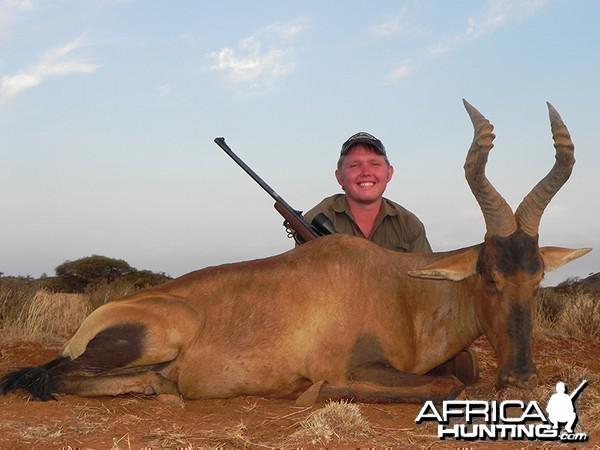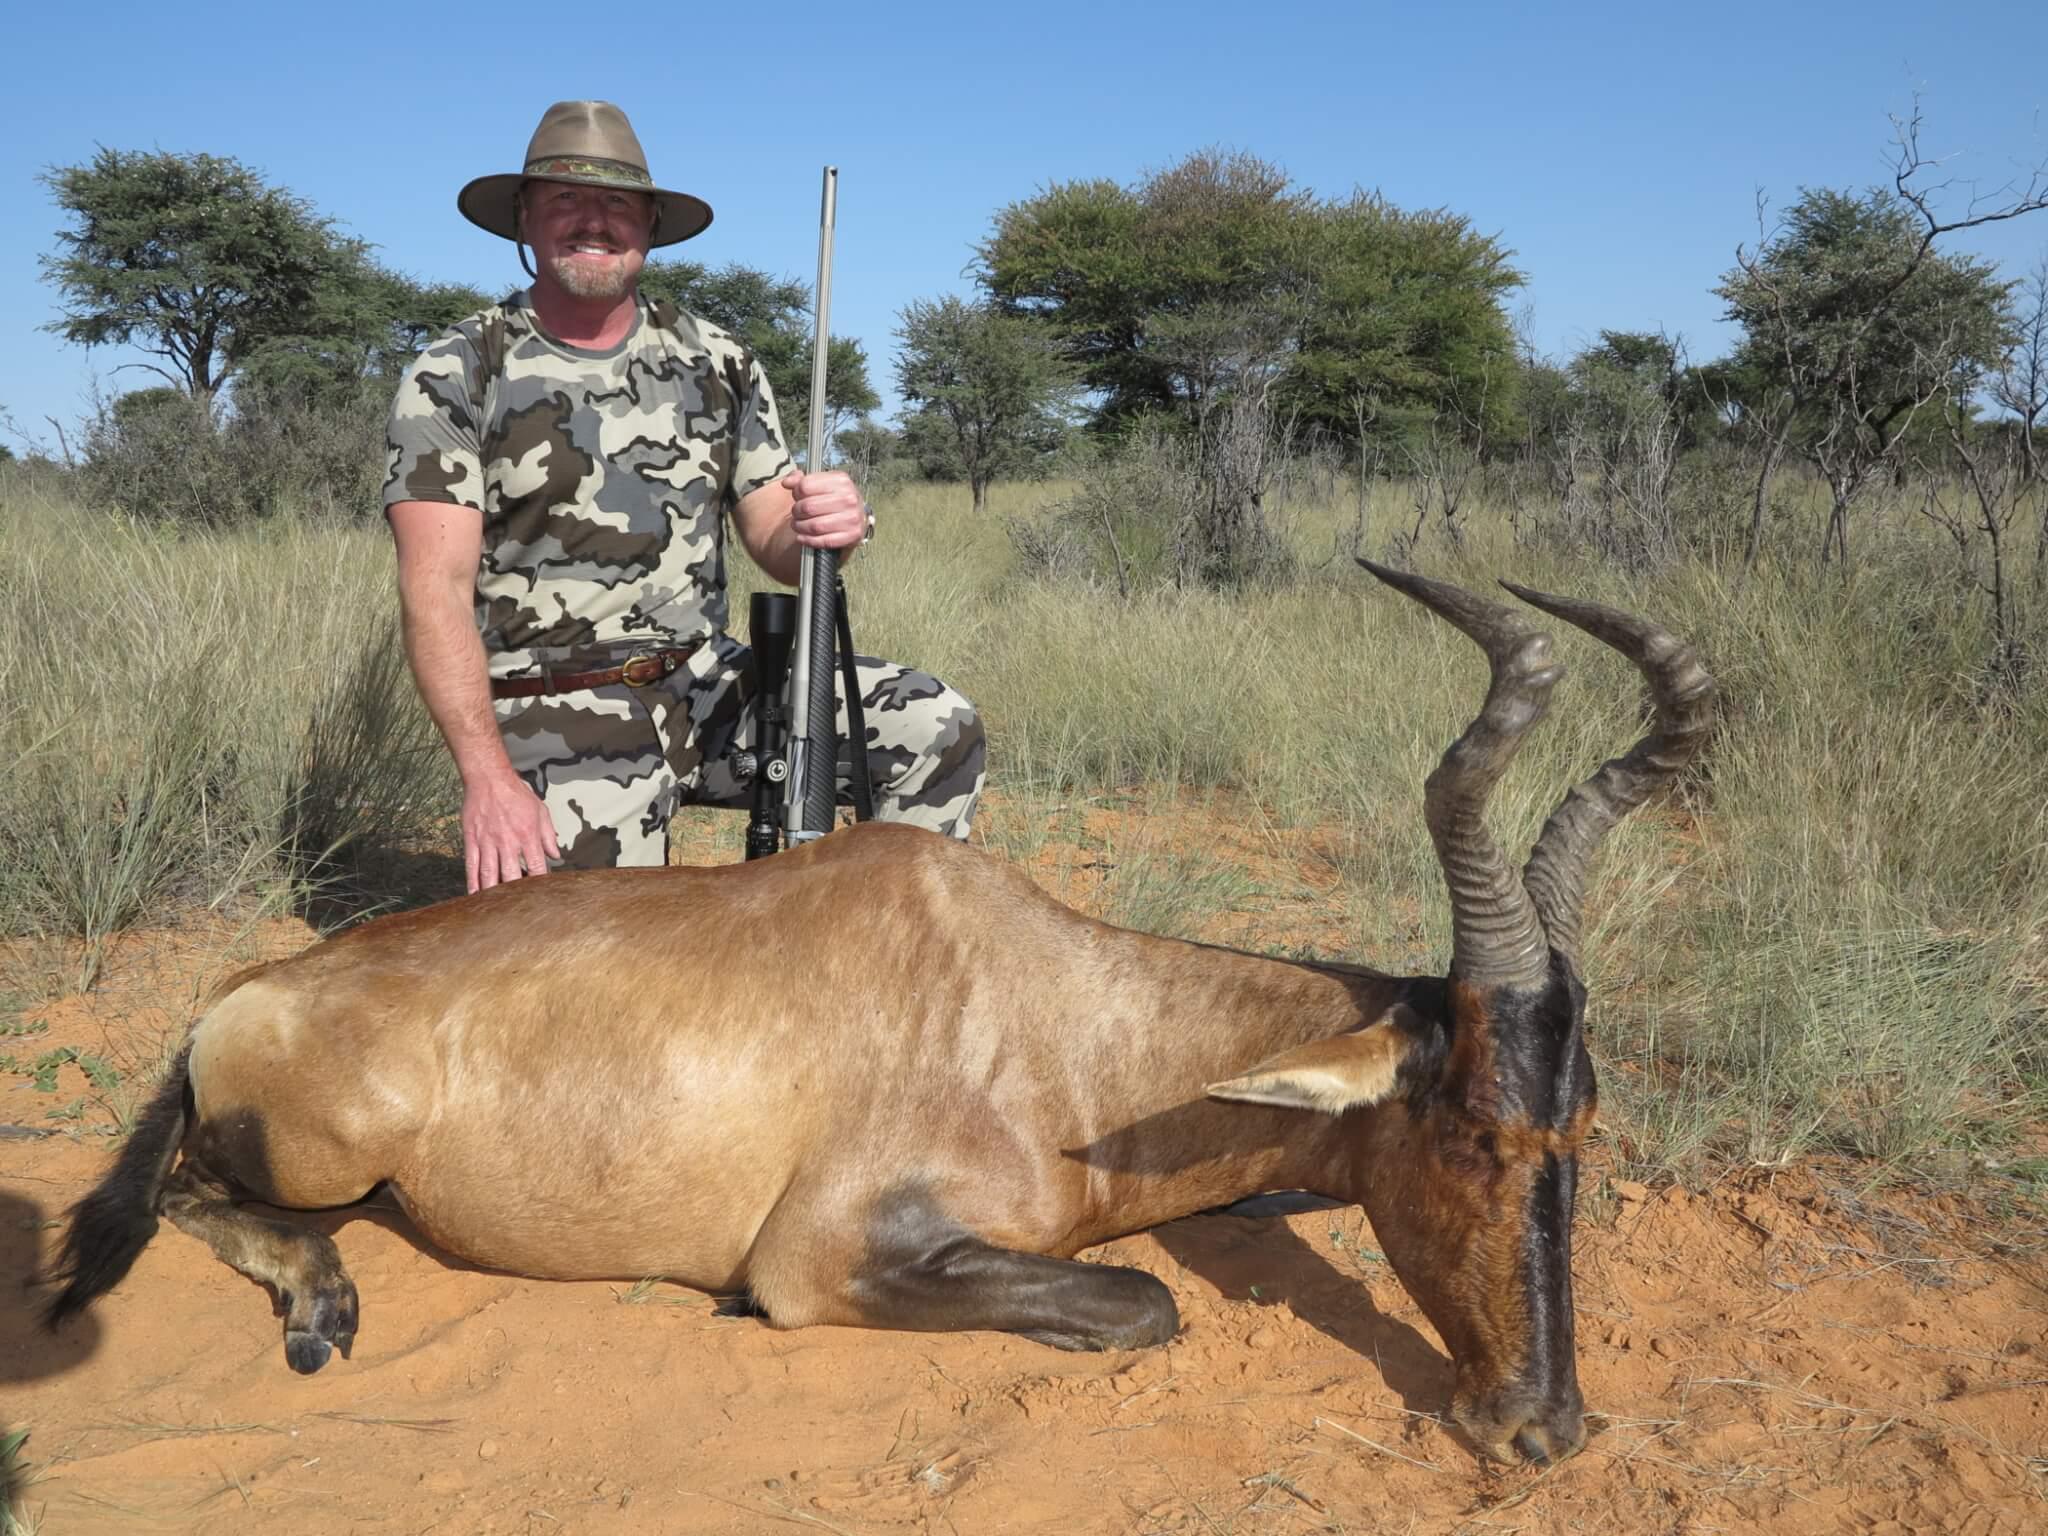The first image is the image on the left, the second image is the image on the right. Considering the images on both sides, is "There are exactly two men." valid? Answer yes or no. Yes. The first image is the image on the left, the second image is the image on the right. Examine the images to the left and right. Is the description "In the right image, a hunter in a brimmed hat holding a rifle vertically is behind a downed horned animal with its head to the right." accurate? Answer yes or no. Yes. 